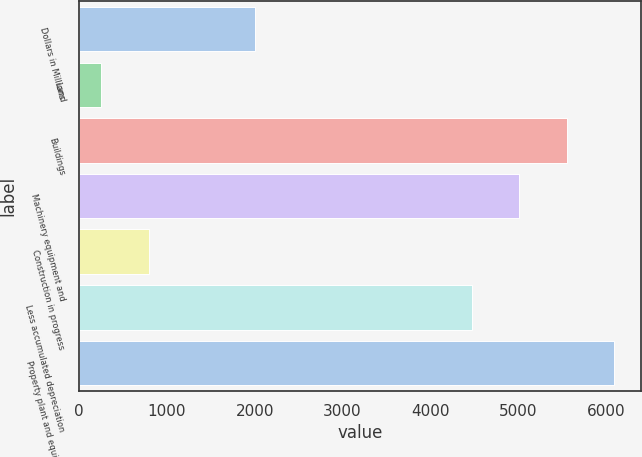Convert chart. <chart><loc_0><loc_0><loc_500><loc_500><bar_chart><fcel>Dollars in Millions<fcel>Land<fcel>Buildings<fcel>Machinery equipment and<fcel>Construction in progress<fcel>Less accumulated depreciation<fcel>Property plant and equipment<nl><fcel>2006<fcel>254<fcel>5554.8<fcel>5012.9<fcel>795.9<fcel>4471<fcel>6096.7<nl></chart> 